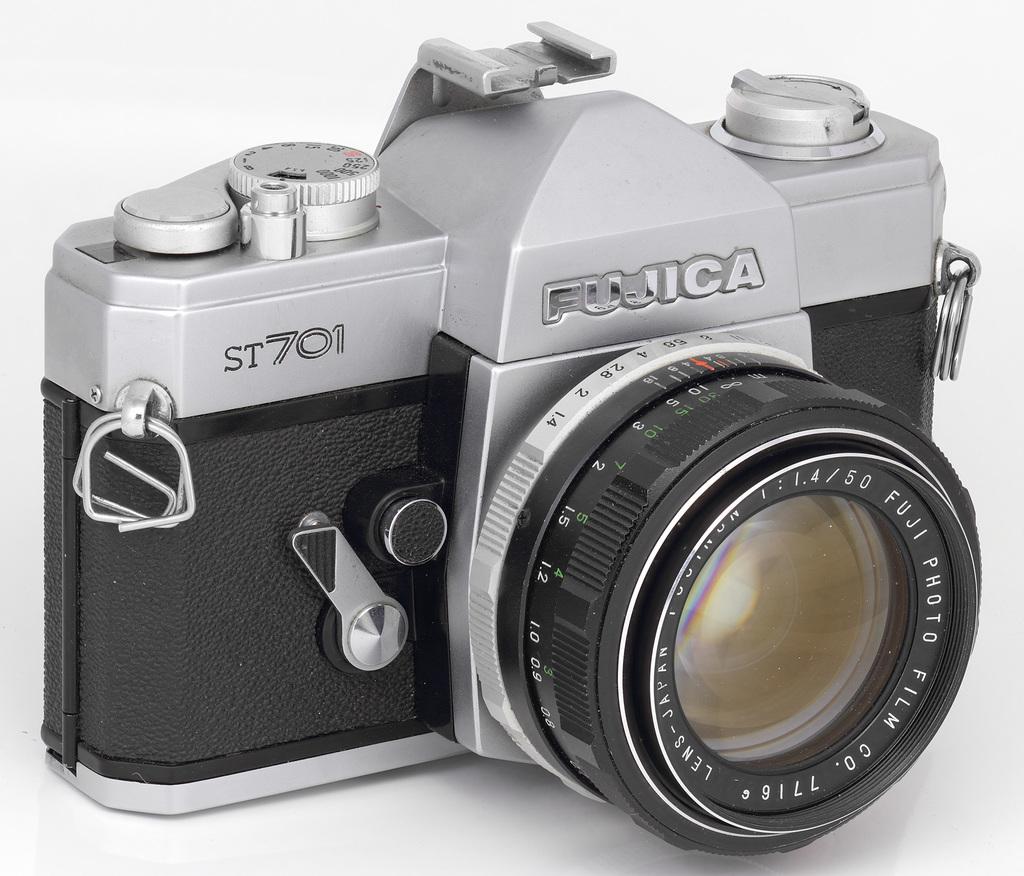What brand of camera is this?
Offer a very short reply. Fujica. 